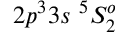Convert formula to latex. <formula><loc_0><loc_0><loc_500><loc_500>{ 2 p ^ { 3 } 3 s ^ { 5 } S _ { 2 } ^ { o } }</formula> 